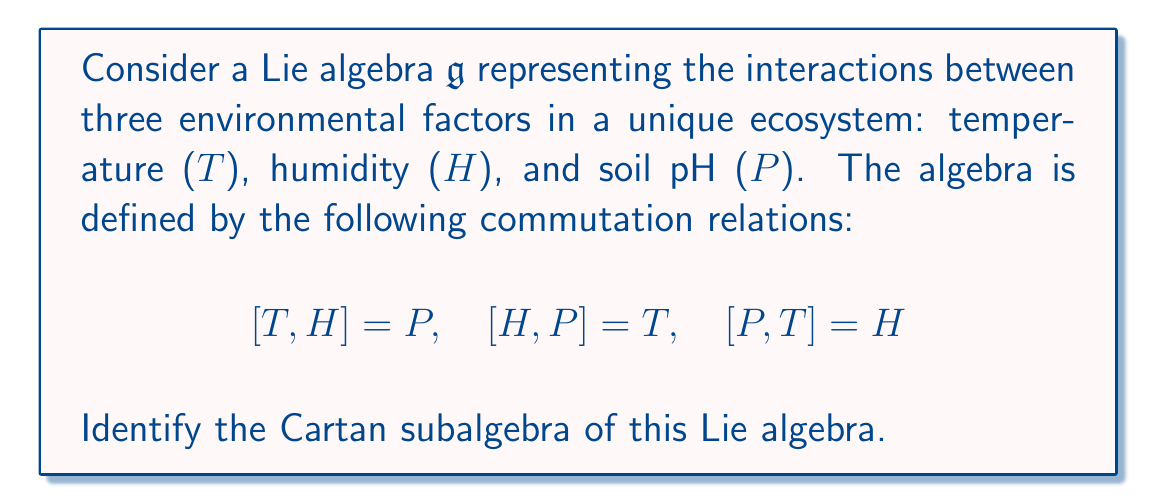Give your solution to this math problem. To identify the Cartan subalgebra of this Lie algebra, we need to follow these steps:

1) Recall that a Cartan subalgebra is a maximal abelian subalgebra consisting of semisimple elements.

2) In this case, we need to find a maximal set of elements that commute with each other.

3) Let's consider a general element $X = aT + bH + cP$ where $a$, $b$, and $c$ are scalars.

4) For $X$ to be in the Cartan subalgebra, it must commute with itself and any other element in the subalgebra.

5) Let's compute $[X,X]$:

   $$\begin{align}
   [X,X] &= [aT + bH + cP, aT + bH + cP] \\
   &= ab[T,H] + ac[T,P] + ba[H,T] + bc[H,P] + ca[P,T] + cb[P,H] \\
   &= abP - acH - baP + bcT + caH - cbT \\
   &= (bc-cb)T + (ca-ac)H + (ab-ba)P \\
   &= 0
   \end{align}$$

6) For this to be zero for all choices of $a$, $b$, and $c$, we must have $a=b=c=0$.

7) This means that the only element that commutes with itself is the zero element.

8) Therefore, the Cartan subalgebra of this Lie algebra is the zero subalgebra $\{0\}$.

This result is consistent with the structure of simple three-dimensional Lie algebras, such as $\mathfrak{so}(3)$ or $\mathfrak{sl}(2,\mathbb{R})$, which have a similar commutation structure and also have a zero Cartan subalgebra.
Answer: The Cartan subalgebra of the given Lie algebra is $\{0\}$, the zero subalgebra. 